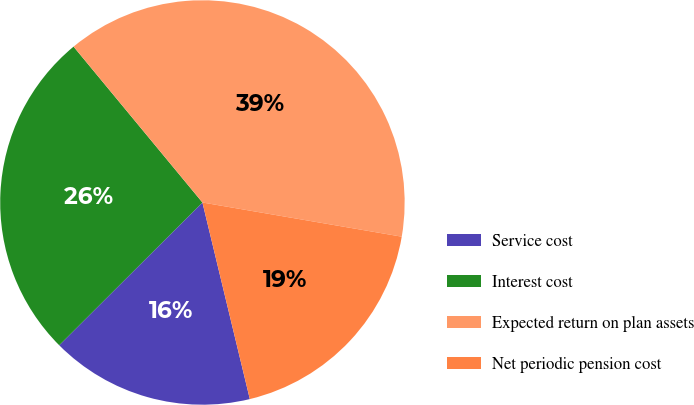<chart> <loc_0><loc_0><loc_500><loc_500><pie_chart><fcel>Service cost<fcel>Interest cost<fcel>Expected return on plan assets<fcel>Net periodic pension cost<nl><fcel>16.29%<fcel>26.48%<fcel>38.7%<fcel>18.53%<nl></chart> 